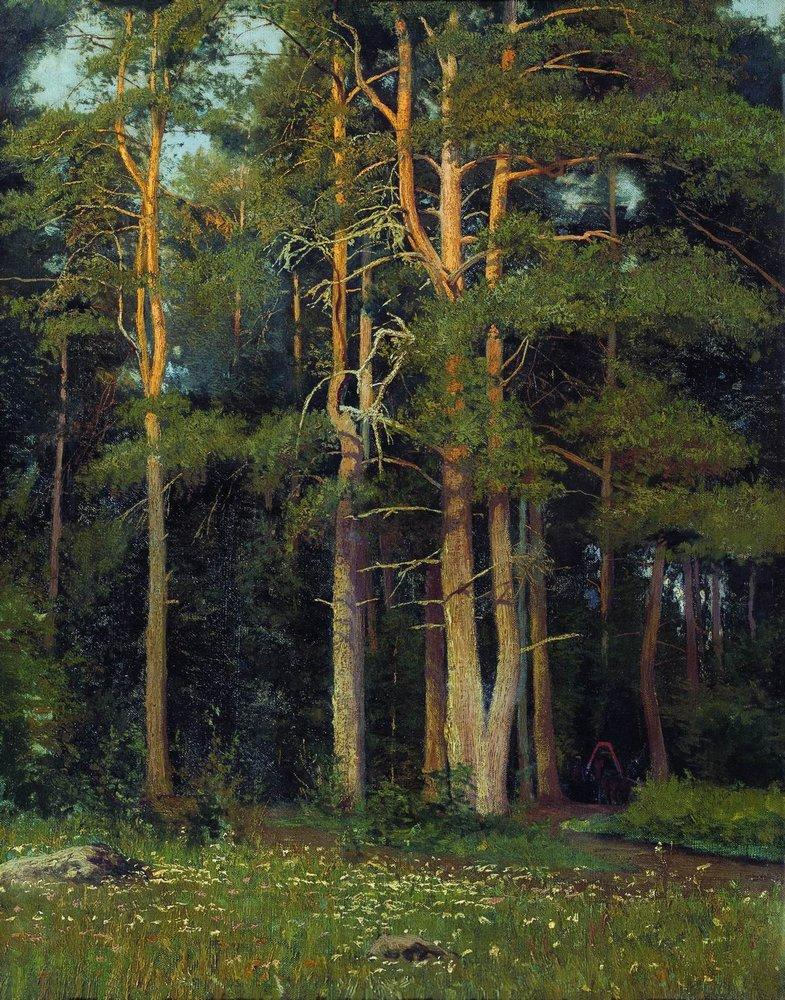Imagine if the trees could talk. What stories might they tell? If the trees in this forest could talk, they would likely share countless tales of the natural world and its inhabitants. They might recount the comings and goings of various animals, from the delicate footsteps of a deer to the playful antics of squirrels. They could speak of the changing seasons, describing the vibrant burst of life in spring, the lush canopy of summer, the colorful transformation in autumn, and the quiet dormancy of winter. They might also tell of ancient events, such as storms that tested their resilience or the slow growth of a sapling into a majestic giant. These trees would be the living archives of the forest, holding within their rings the history of the landscape and the life that flourishes within it. What mythical creature could you envision living in this forest? In a forest as enchanting as this, one might imagine the presence of a majestic forest guardian, perhaps an ancient dryad. This mythical creature would be a tree spirit, deeply connected to the woods. She would wander the forest, nurturing the plant life, ensuring the balance of the ecosystem, and whispering to the trees. Her presence would be felt more than seen, a gentle rustling of leaves or a fleeting glimpse of a graceful figure among the trunks. The animals would trust her, and the flowers would bloom where she stepped, making the forest a place of magic and harmony. 